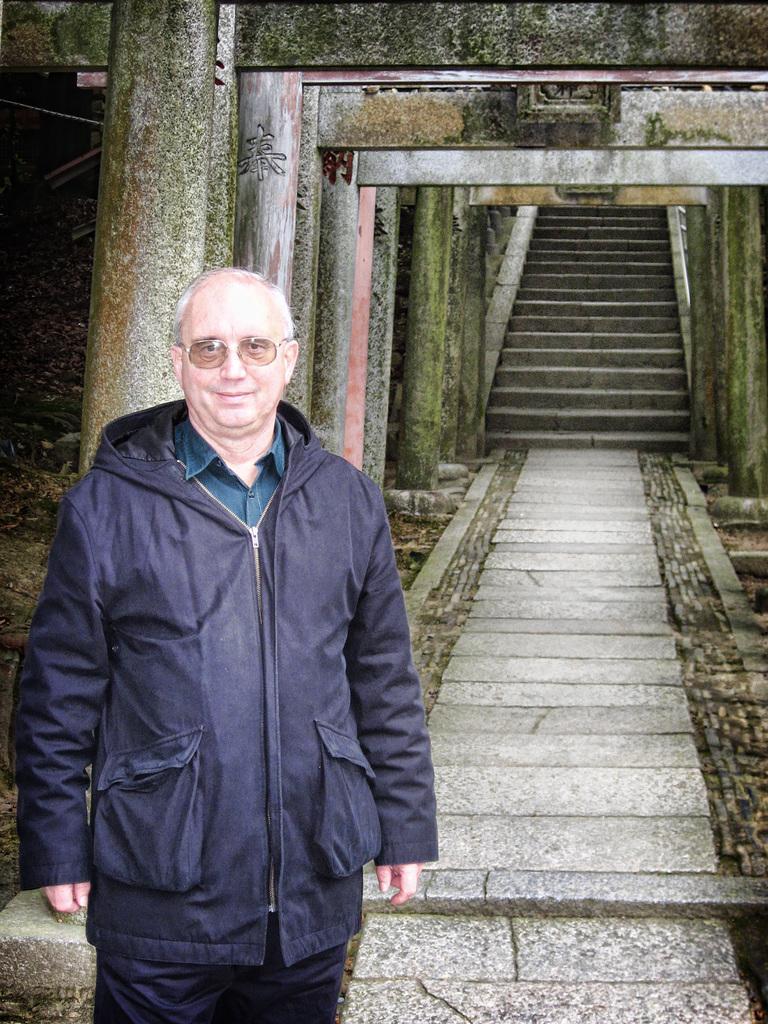In one or two sentences, can you explain what this image depicts? In the image there is an old man in navy blue jacket standing on the left side, behind him there is path followed by steps, this seems to be an ancient building. 